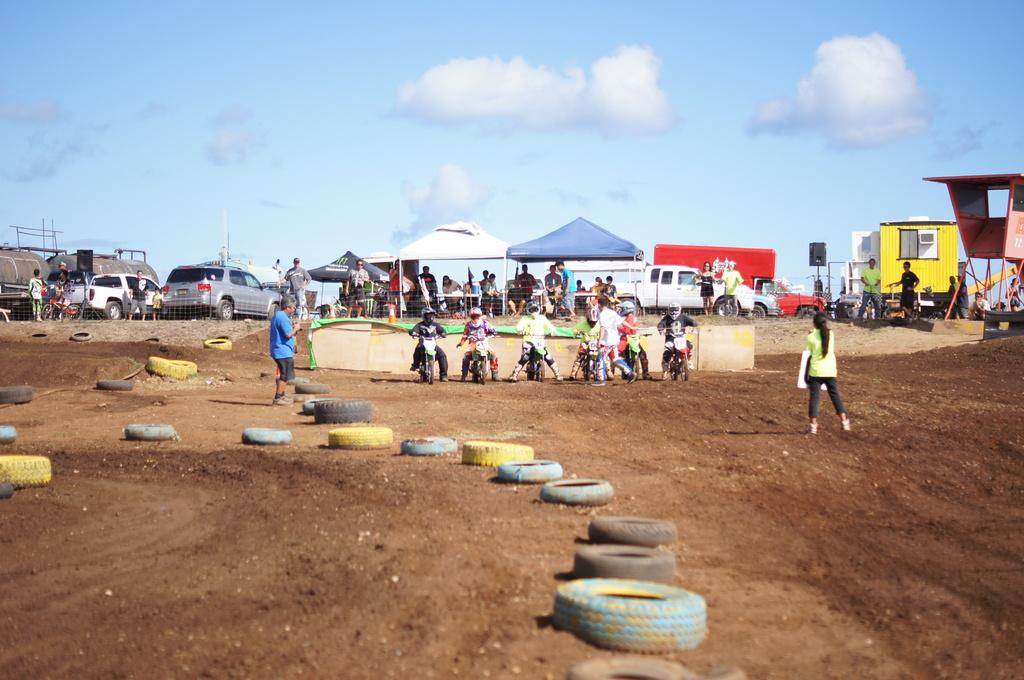What objects are on the ground in the image? There are tyres on the ground in the image. What are the people in the center of the image doing? The people in the center of the image are on bikes. What can be seen in the background of the image? There are vehicles, people, tents, a shed, a speaker, and the sky visible in the background. What type of breakfast is being served in the image? There is no breakfast present in the image. What emotion is the bike feeling in the image? Bikes do not have emotions, so it is not possible to determine what emotion the bike might be feeling. 